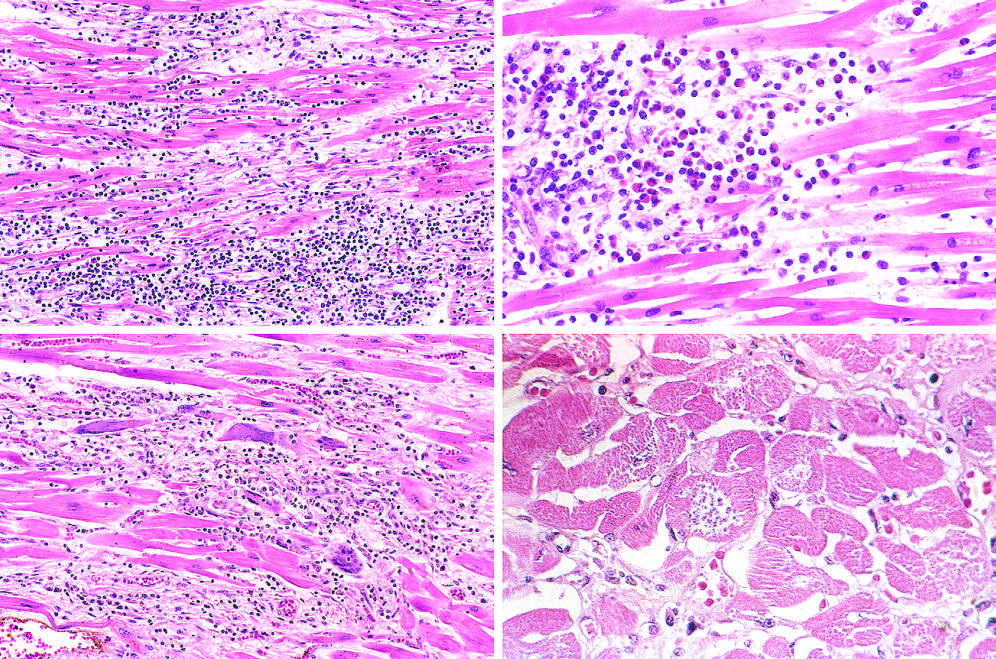what is present, along with mononuclear inflammation and myofiber necrosis?
Answer the question using a single word or phrase. A myofiber distended with trypanosomes 